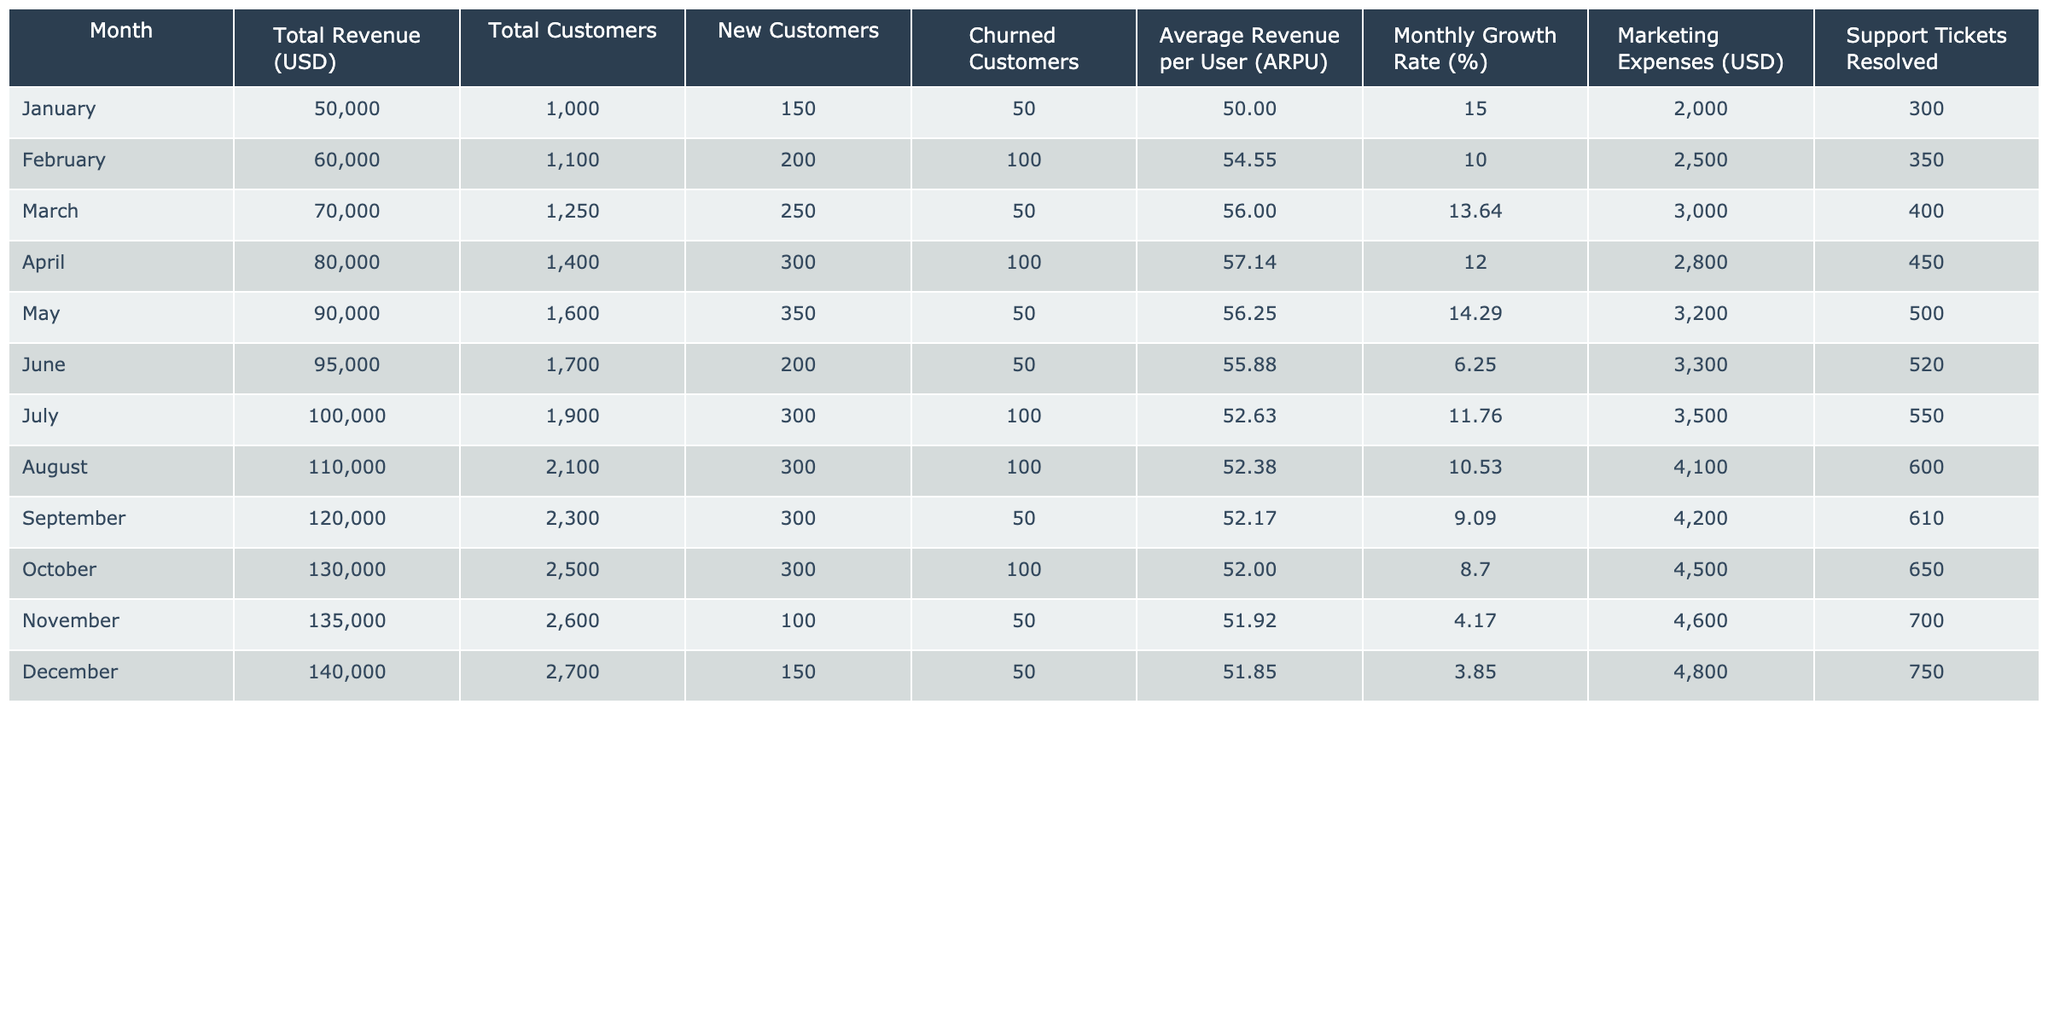What was the total revenue in March? Referring to the table, the total revenue for March is explicitly listed. In March, the total revenue is 70,000 USD.
Answer: 70,000 USD What is the average revenue per user (ARPU) in December? The ARPU for December is provided directly in the table as 51.85.
Answer: 51.85 How many new customers were added in June? The table shows that in June, the new customers added were 200.
Answer: 200 What is the monthly growth rate for October? According to the table, the monthly growth rate for October is 8.70%.
Answer: 8.70% Which month had the highest total customers? By checking the total customers column in the table, December has the highest total customers with 2,700.
Answer: 2,700 What was the total customer growth from January to December? To find total customer growth, subtract the total customers in January (1,000) from those in December (2,700). Thus, 2,700 - 1,000 = 1,700.
Answer: 1,700 Did the ARPU decrease from July to August? In July, ARPU is 52.63 and in August, it's 52.38. Since 52.38 < 52.63, the ARPU did decrease.
Answer: Yes In which month did customer churn reach 100? The table indicates that customer churn was 100 in February, April, and July.
Answer: February, April, July What was the total marketing expense for the first half of the year? The marketing expenses from January to June are 2,000 + 2,500 + 3,000 + 2,800 + 3,200 + 3,300 = 16,800 USD.
Answer: 16,800 USD Was the average revenue per user (ARPU) higher in November or December? The ARPU in November is 51.92, while in December it is 51.85. Therefore, since 51.92 > 51.85, November had a higher ARPU.
Answer: November 